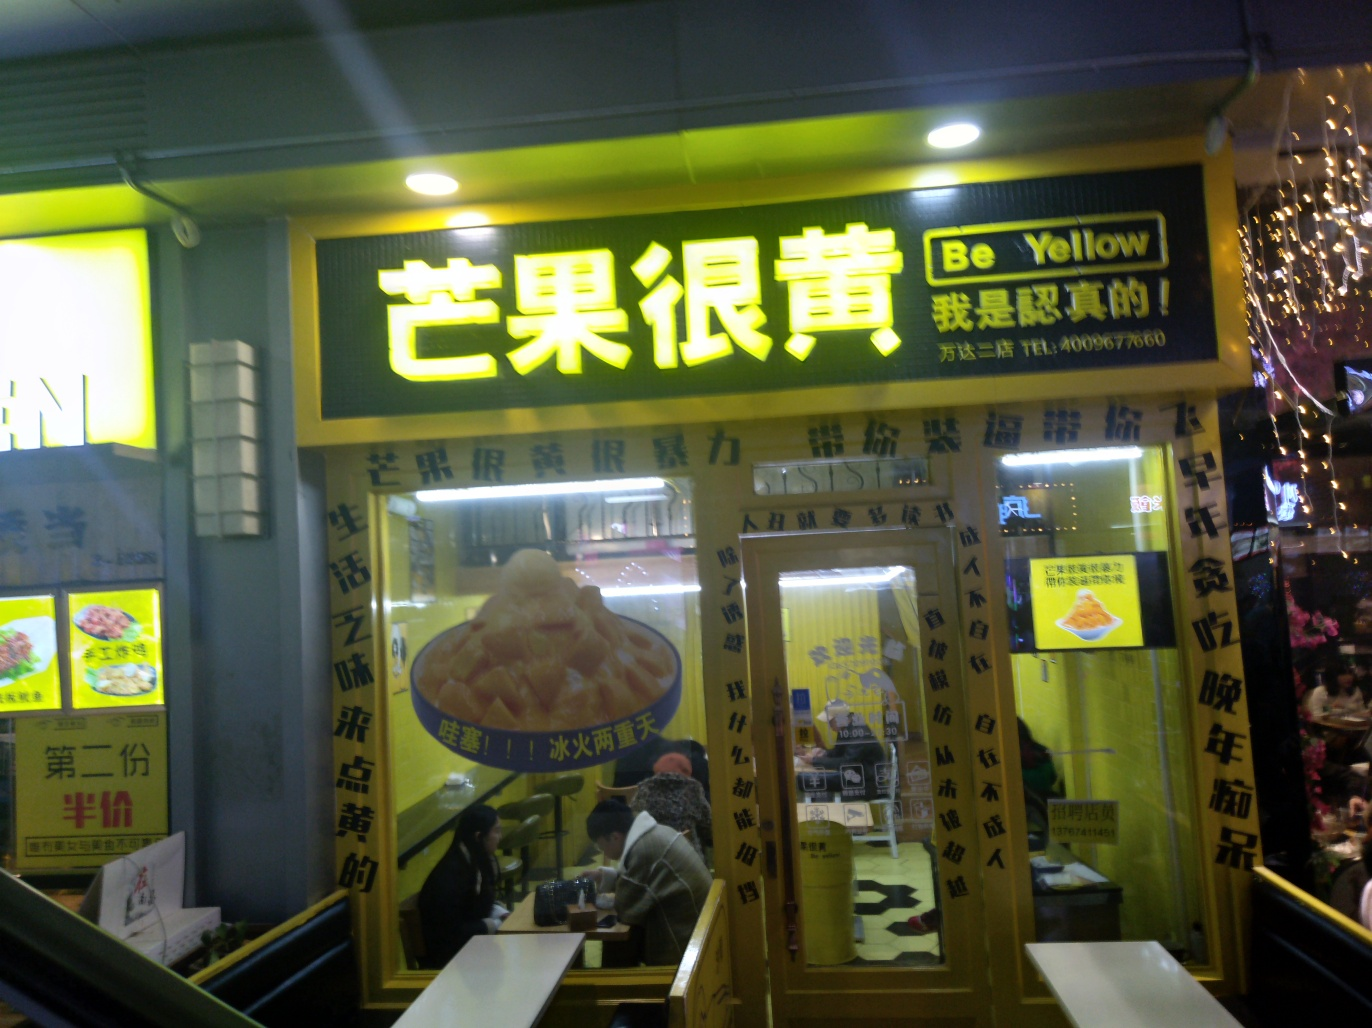Describe the ambiance of this place based on the image. The ambiance of the restaurant comes across as casual and welcoming, with bright yellow colors dominating the storefront. The interior lighting is warm, inviting passersby to enter. Patrons can be seen dining inside, suggesting a comfortable and relaxed atmosphere often associated with eateries where quick, satisfying meals are served. 